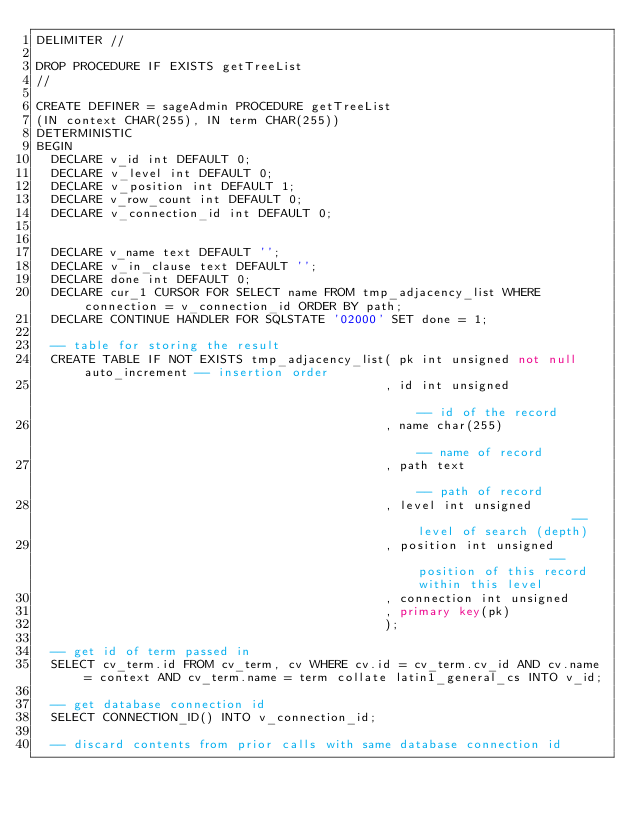Convert code to text. <code><loc_0><loc_0><loc_500><loc_500><_SQL_>DELIMITER //

DROP PROCEDURE IF EXISTS getTreeList
//

CREATE DEFINER = sageAdmin PROCEDURE getTreeList
(IN context CHAR(255), IN term CHAR(255))
DETERMINISTIC
BEGIN
  DECLARE v_id int DEFAULT 0;
  DECLARE v_level int DEFAULT 0;
  DECLARE v_position int DEFAULT 1;
  DECLARE v_row_count int DEFAULT 0;
  DECLARE v_connection_id int DEFAULT 0;


  DECLARE v_name text DEFAULT '';
  DECLARE v_in_clause text DEFAULT '';
  DECLARE done int DEFAULT 0;
  DECLARE cur_1 CURSOR FOR SELECT name FROM tmp_adjacency_list WHERE connection = v_connection_id ORDER BY path;
  DECLARE CONTINUE HANDLER FOR SQLSTATE '02000' SET done = 1;

  -- table for storing the result
  CREATE TABLE IF NOT EXISTS tmp_adjacency_list( pk int unsigned not null auto_increment -- insertion order
                                               , id int unsigned                         -- id of the record
                                               , name char(255)                          -- name of record
                                               , path text                               -- path of record
                                               , level int unsigned                      -- level of search (depth)
                                               , position int unsigned                   -- position of this record within this level
                                               , connection int unsigned
                                               , primary key(pk)
                                               );

  -- get id of term passed in 
  SELECT cv_term.id FROM cv_term, cv WHERE cv.id = cv_term.cv_id AND cv.name = context AND cv_term.name = term collate latin1_general_cs INTO v_id;

  -- get database connection id
  SELECT CONNECTION_ID() INTO v_connection_id;

  -- discard contents from prior calls with same database connection id</code> 